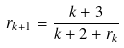<formula> <loc_0><loc_0><loc_500><loc_500>r _ { k + 1 } = \frac { k + 3 } { k + 2 + r _ { k } }</formula> 